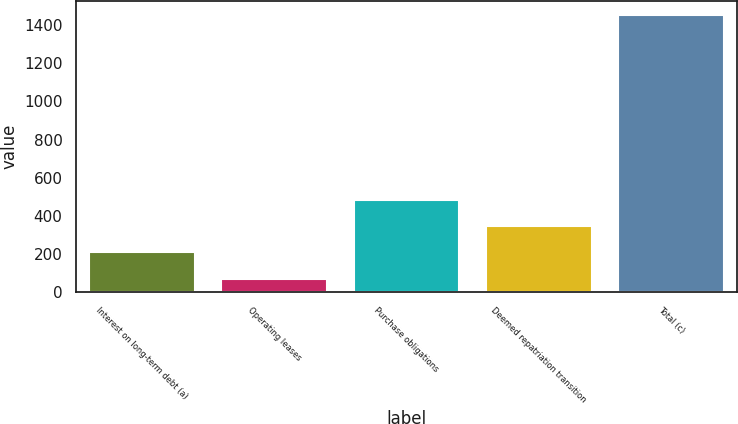<chart> <loc_0><loc_0><loc_500><loc_500><bar_chart><fcel>Interest on long-term debt (a)<fcel>Operating leases<fcel>Purchase obligations<fcel>Deemed repatriation transition<fcel>Total (c)<nl><fcel>209.1<fcel>71<fcel>485.3<fcel>347.2<fcel>1452<nl></chart> 